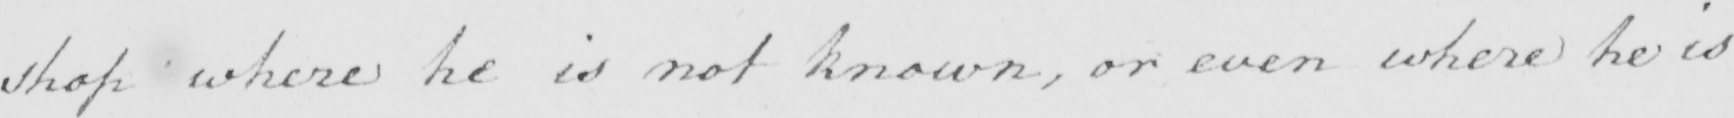Can you tell me what this handwritten text says? shop where he is not know , or even where he is 